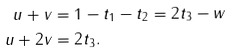Convert formula to latex. <formula><loc_0><loc_0><loc_500><loc_500>u + v & = 1 - t _ { 1 } - t _ { 2 } = 2 t _ { 3 } - w \\ u + 2 v & = 2 t _ { 3 } .</formula> 